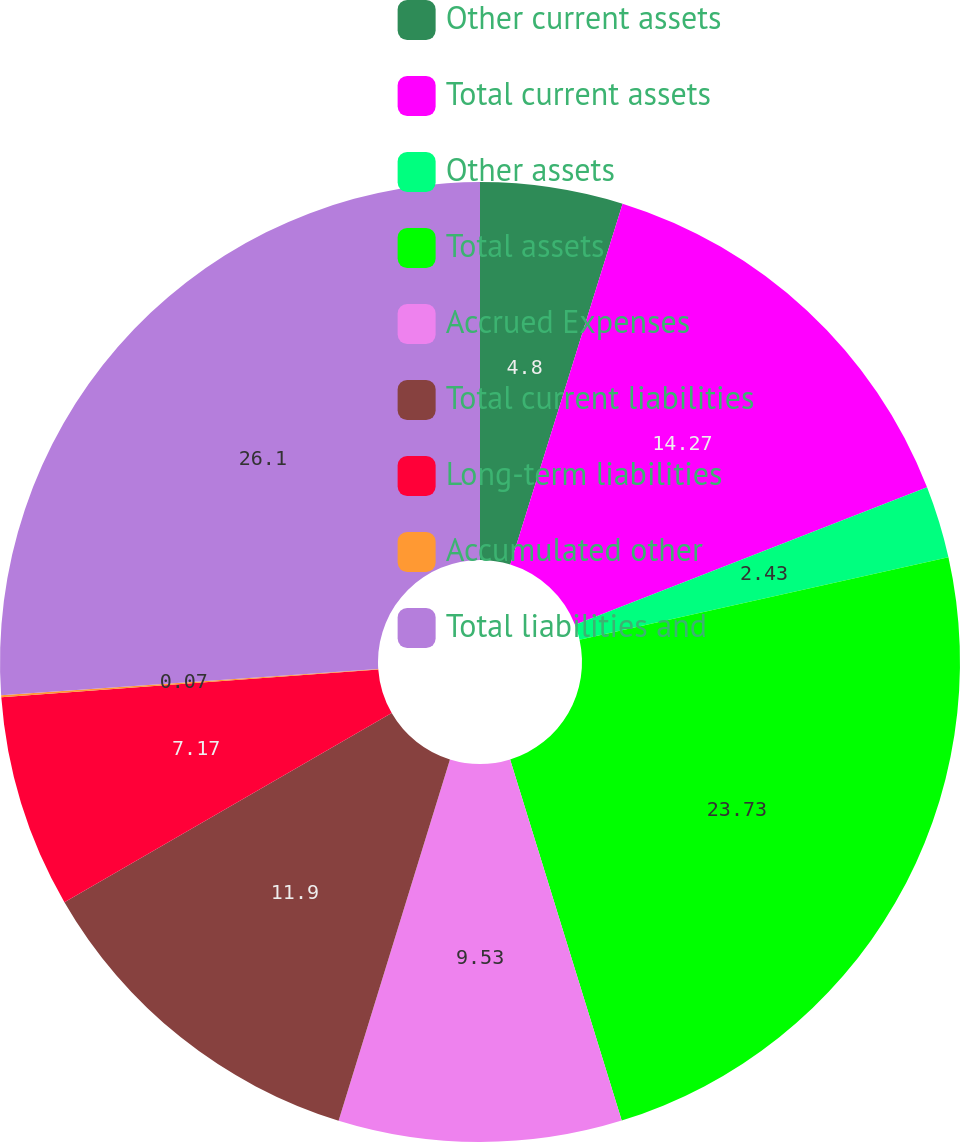Convert chart to OTSL. <chart><loc_0><loc_0><loc_500><loc_500><pie_chart><fcel>Other current assets<fcel>Total current assets<fcel>Other assets<fcel>Total assets<fcel>Accrued Expenses<fcel>Total current liabilities<fcel>Long-term liabilities<fcel>Accumulated other<fcel>Total liabilities and<nl><fcel>4.8%<fcel>14.27%<fcel>2.43%<fcel>23.73%<fcel>9.53%<fcel>11.9%<fcel>7.17%<fcel>0.07%<fcel>26.1%<nl></chart> 